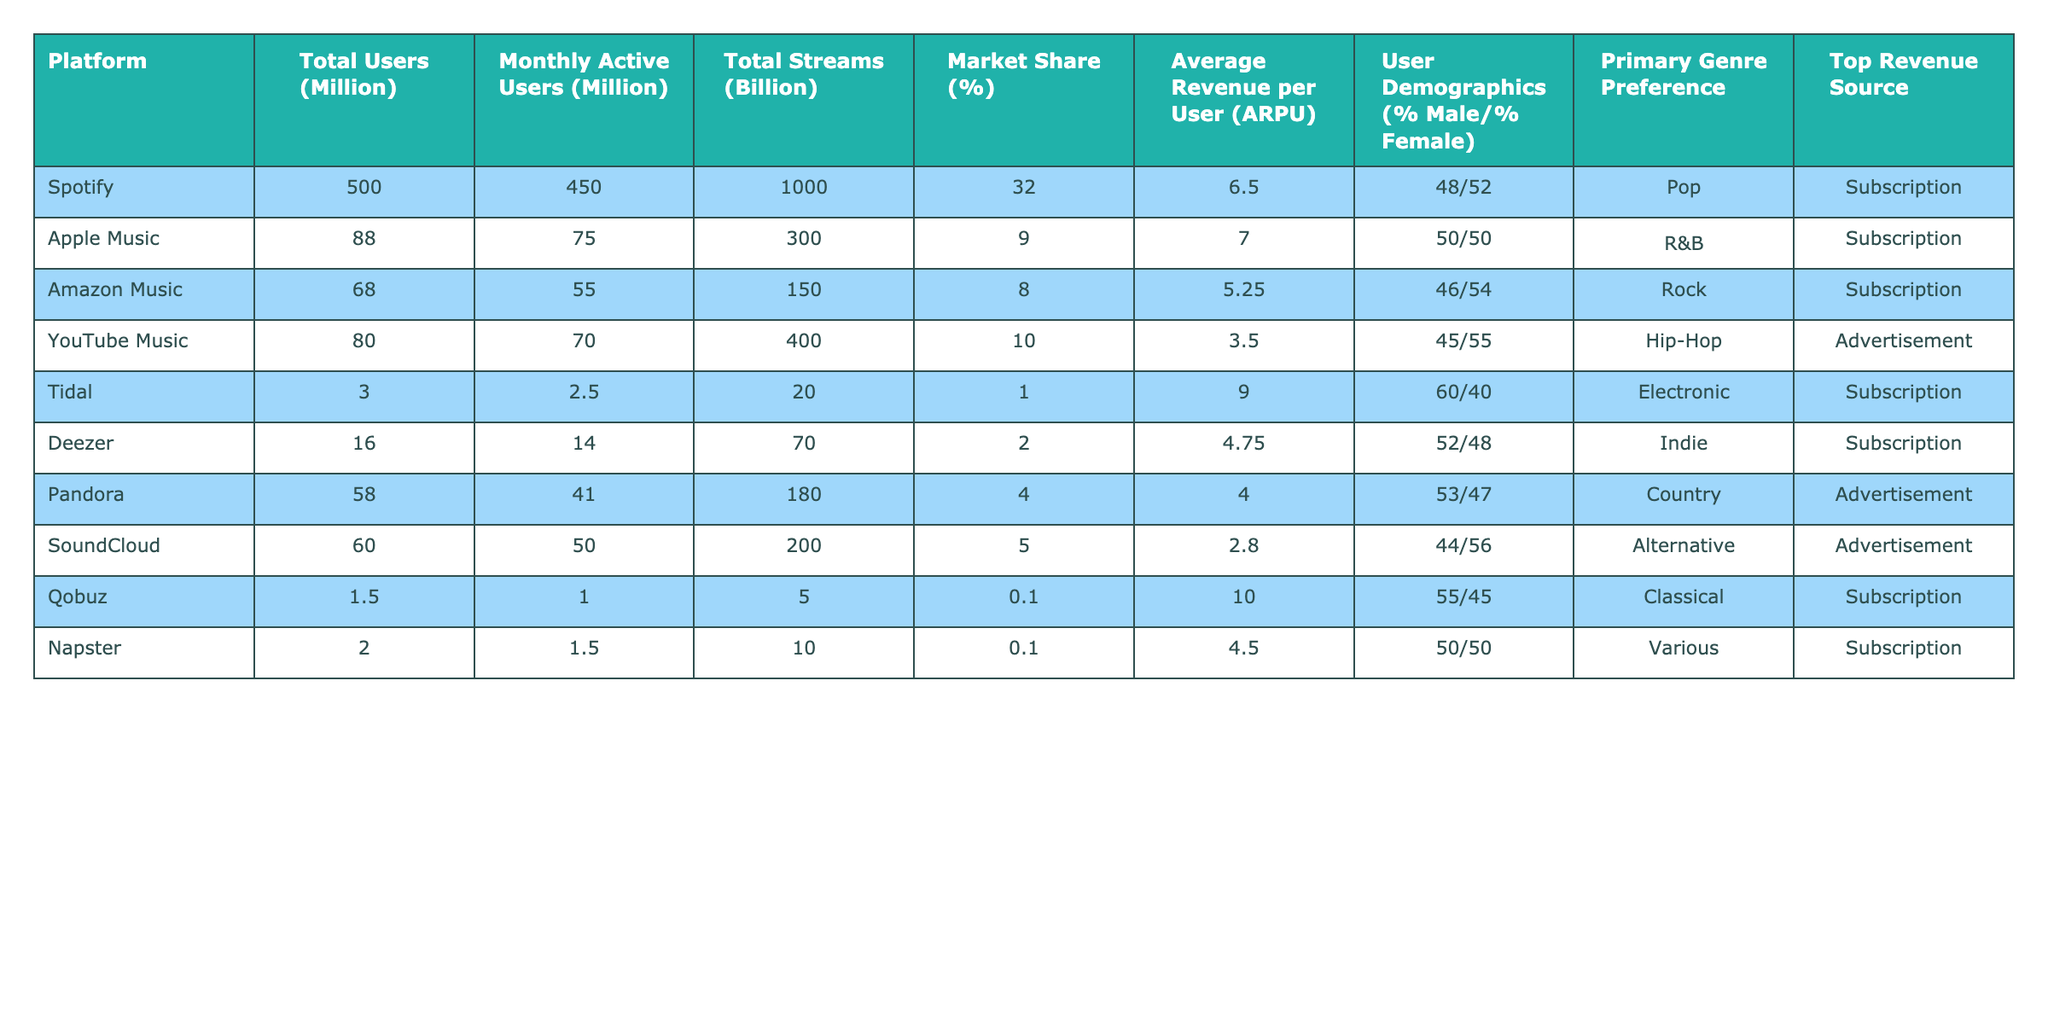What is the total number of users on Spotify? The table indicates that the total users on Spotify is listed under the "Total Users (Million)" column, which shows 500 million.
Answer: 500 million Which platform has the highest average revenue per user? By comparing the "Average Revenue per User (ARPU)" values across all platforms, Tidal has the highest ARPU at $9.00.
Answer: Tidal What is the market share percentage of Apple Music? The table shows Apple Music's market share percentage in the "Market Share (%)" column, which is 9%.
Answer: 9% How many total streams does YouTube Music have? The total streams for YouTube Music is found in the "Total Streams (Billion)" column, which states 400 billion streams.
Answer: 400 billion Which platform has a user demographic of 60% male? Looking at the "User Demographics (%)" column, Tidal is the platform listed with a 60% male demographic.
Answer: Tidal What is the difference between the total streams of Spotify and Apple Music? The total streams of Spotify are 1000 billion, while Apple Music has 300 billion. The difference is calculated as 1000 - 300 = 700 billion.
Answer: 700 billion Is there a platform with more than 400 million total users? The table indicates that Spotify is the only platform with total users exceeding 400 million, reaching 500 million.
Answer: Yes Which platform has the lowest market share? The lowest market share percentage is found in the table for the platform Qobuz, which is at 0.1%.
Answer: Qobuz What is the average total streams for the platforms listed? To find the average, sum the total streams for all platforms (1000 + 300 + 150 + 400 + 20 + 70 + 180 + 200 + 5 + 10 = 2335) and divide by the number of platforms (10). The average is 2335 / 10 = 233.5 billion.
Answer: 233.5 billion Which platform generates revenue primarily from advertisements? The columns indicate that both YouTube Music and Pandora generate revenue primarily through advertisements.
Answer: YouTube Music and Pandora 